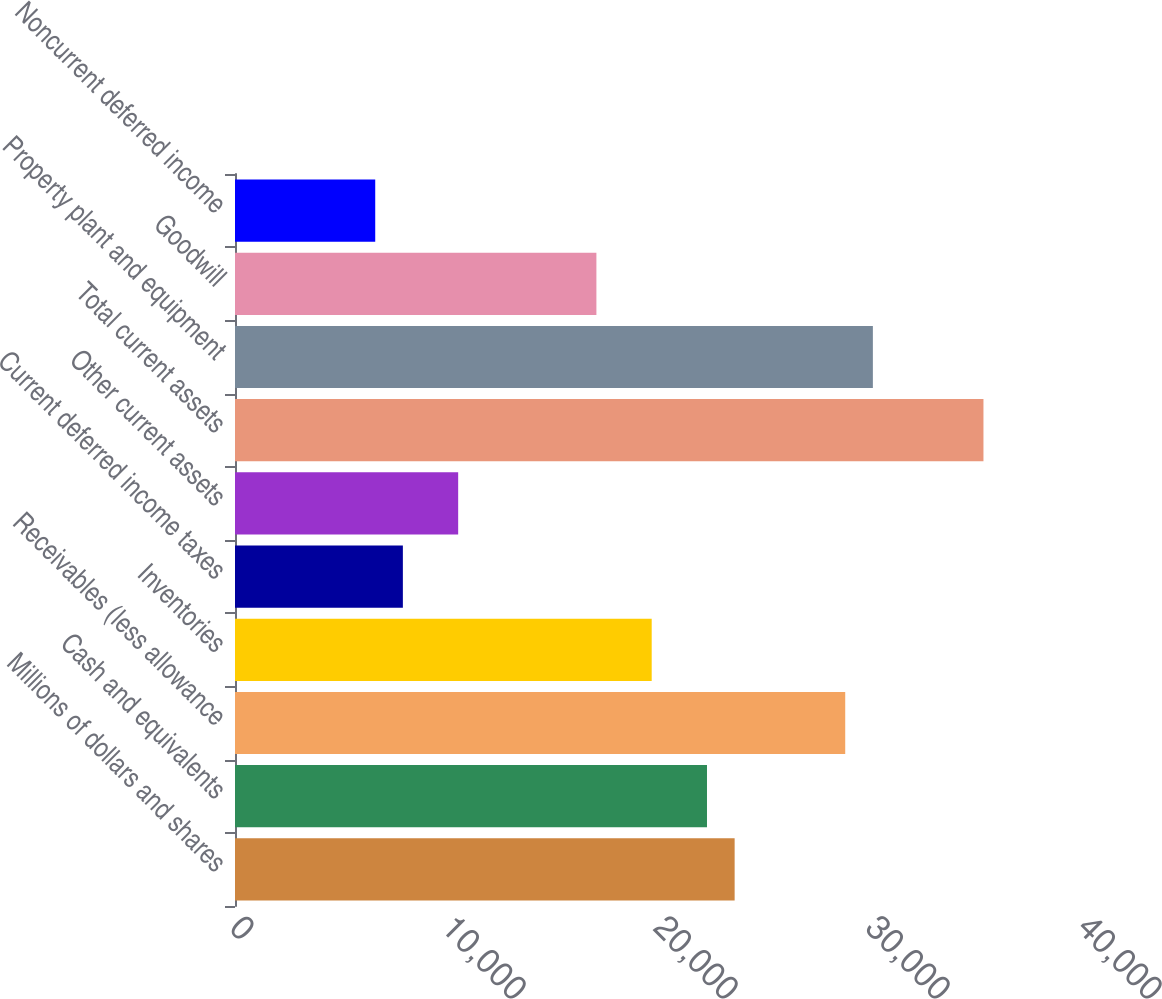Convert chart. <chart><loc_0><loc_0><loc_500><loc_500><bar_chart><fcel>Millions of dollars and shares<fcel>Cash and equivalents<fcel>Receivables (less allowance<fcel>Inventories<fcel>Current deferred income taxes<fcel>Other current assets<fcel>Total current assets<fcel>Property plant and equipment<fcel>Goodwill<fcel>Noncurrent deferred income<nl><fcel>23567.8<fcel>22263.7<fcel>28784.2<fcel>19655.5<fcel>7918.6<fcel>10526.8<fcel>35304.7<fcel>30088.3<fcel>17047.3<fcel>6614.5<nl></chart> 